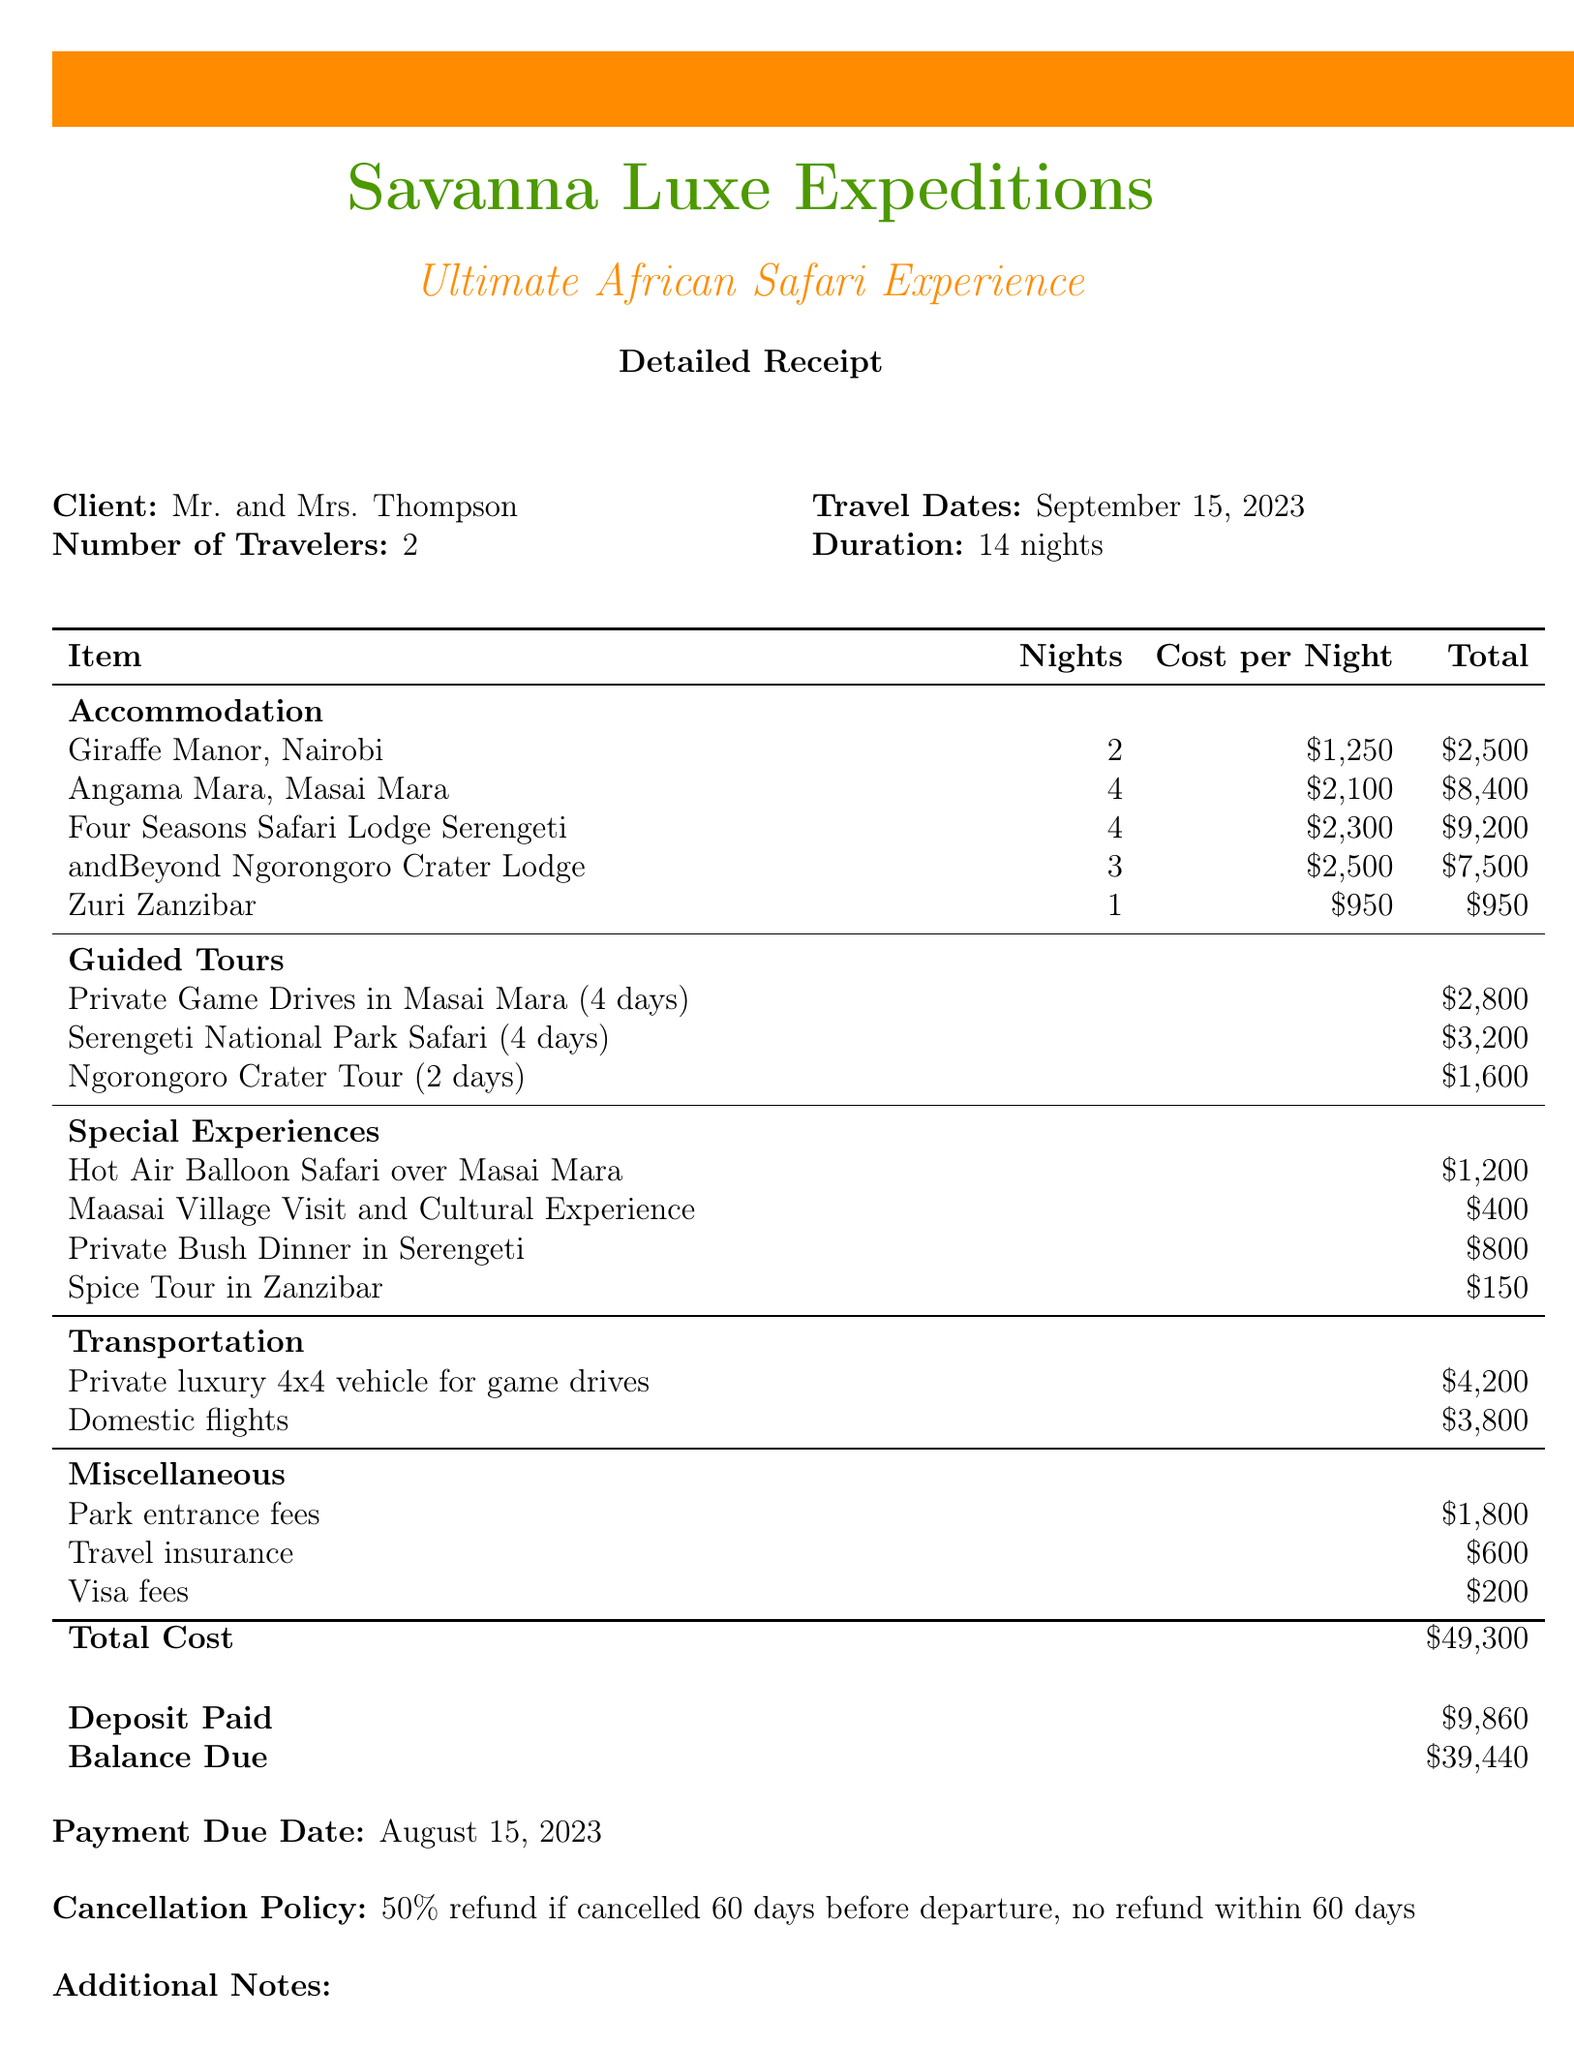What is the travel agency name? The travel agency name is provided at the top of the document, which is Savanna Luxe Expeditions.
Answer: Savanna Luxe Expeditions How many nights is the safari package? The duration of the safari package is specified in the document as 14 nights.
Answer: 14 nights What is the total cost of the package? The total cost is presented at the end of the document as the final amount for the entire package.
Answer: $49,300 What is the deposit amount paid? The amount already paid as a deposit is explicitly mentioned in the financial section of the receipt.
Answer: $9,860 What is the payment due date? The date by which the remaining balance must be paid is listed in the financial section of the document.
Answer: August 15, 2023 How many guided tours are included in the package? The document itemizes the guided tours, and there are three different tours mentioned.
Answer: 3 What is the cancellation policy? The cancellation policy is outlined toward the end of the document detailing the refund terms.
Answer: 50% refund if cancelled 60 days before departure, no refund within 60 days What special experience includes a hot air balloon? The special experience identified in the document is a hot air balloon safari over Masai Mara, which is specifically named.
Answer: Hot Air Balloon Safari over Masai Mara How much does the visa fees cost? The cost associated with visa fees is listed among miscellaneous expenses in the document.
Answer: $200 